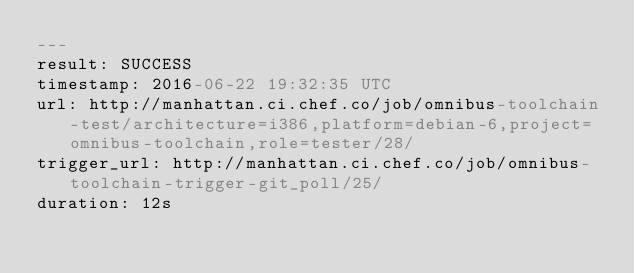<code> <loc_0><loc_0><loc_500><loc_500><_YAML_>---
result: SUCCESS
timestamp: 2016-06-22 19:32:35 UTC
url: http://manhattan.ci.chef.co/job/omnibus-toolchain-test/architecture=i386,platform=debian-6,project=omnibus-toolchain,role=tester/28/
trigger_url: http://manhattan.ci.chef.co/job/omnibus-toolchain-trigger-git_poll/25/
duration: 12s
</code> 